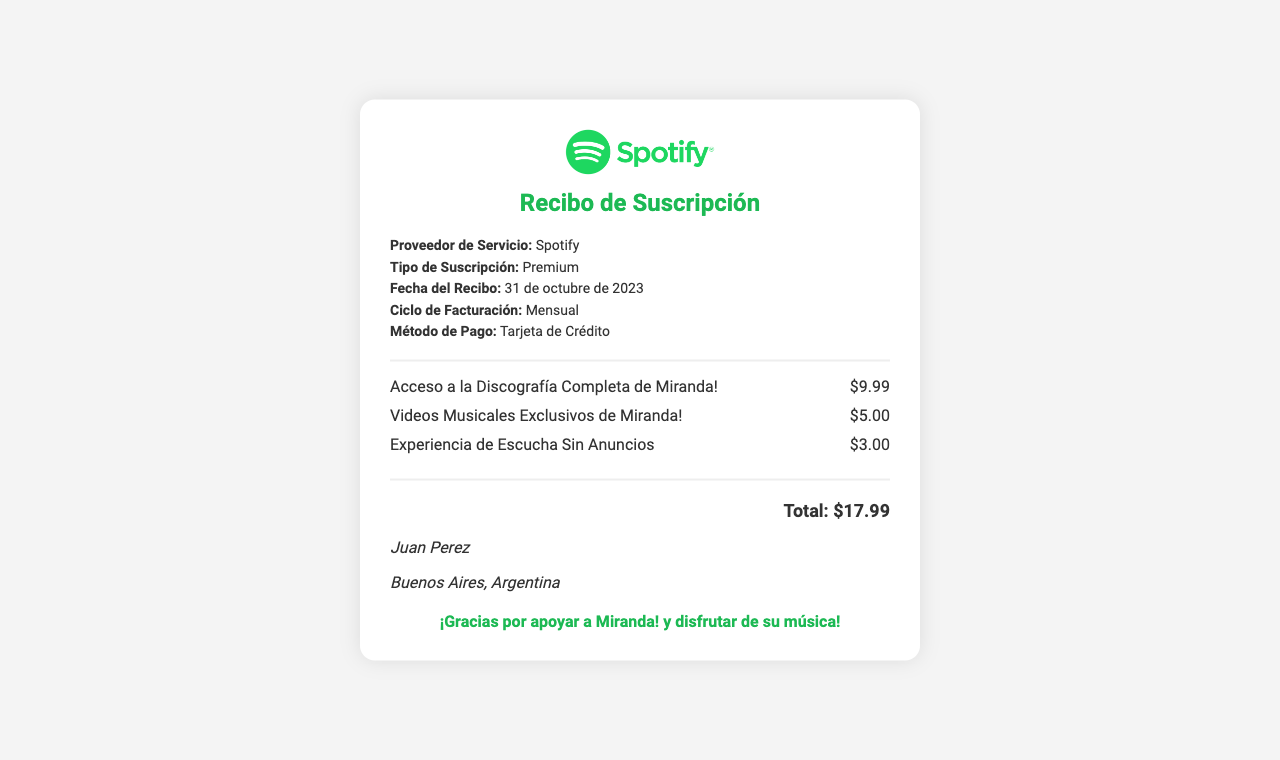What is the service provider? The service provider is mentioned clearly in the receipt as "Spotify."
Answer: Spotify What is the subscription type? The type of subscription is specified in the document as "Premium."
Answer: Premium What date is the receipt issued? The date of the receipt is explicitly stated as "31 de octubre de 2023."
Answer: 31 de octubre de 2023 How much is the charge for accessing Miranda!'s complete discography? The specific charge for the discography is listed as "$9.99."
Answer: $9.99 What is the total amount charged? The total amount is summarized at the bottom of the receipt, which is "$17.99."
Answer: $17.99 What additional feature is included for $3.00? This feature is described as "Experiencia de Escucha Sin Anuncios."
Answer: Experiencia de Escucha Sin Anuncios Who is the customer listed on the receipt? The customer information shows the name "Juan Perez."
Answer: Juan Perez What is the method of payment? The document indicates that the method of payment used is "Tarjeta de Crédito."
Answer: Tarjeta de Crédito What city is the customer from? The customer’s location is given as "Buenos Aires, Argentina."
Answer: Buenos Aires, Argentina What is the message at the bottom of the receipt? The document thanks the user for their support of Miranda! and enjoying their music.
Answer: ¡Gracias por apoyar a Miranda! y disfrutar de su música! 